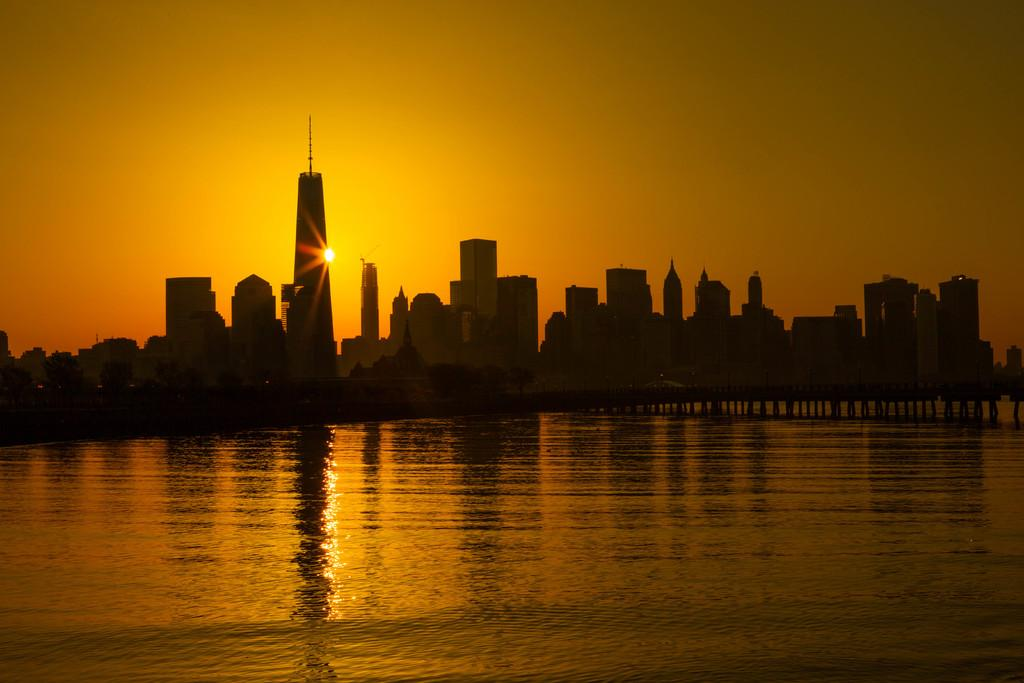What is the primary element visible in the image? There is water in the image. What can be seen in the distance behind the water? There are buildings in the background of the image. What celestial body is visible in the sky in the middle of the image? The sun is visible in the sky in the middle of the image. What is the limit of the payment required for the water in the image? There is no payment or limit mentioned in the image, as it is a natural scene featuring water, buildings, and the sun. 